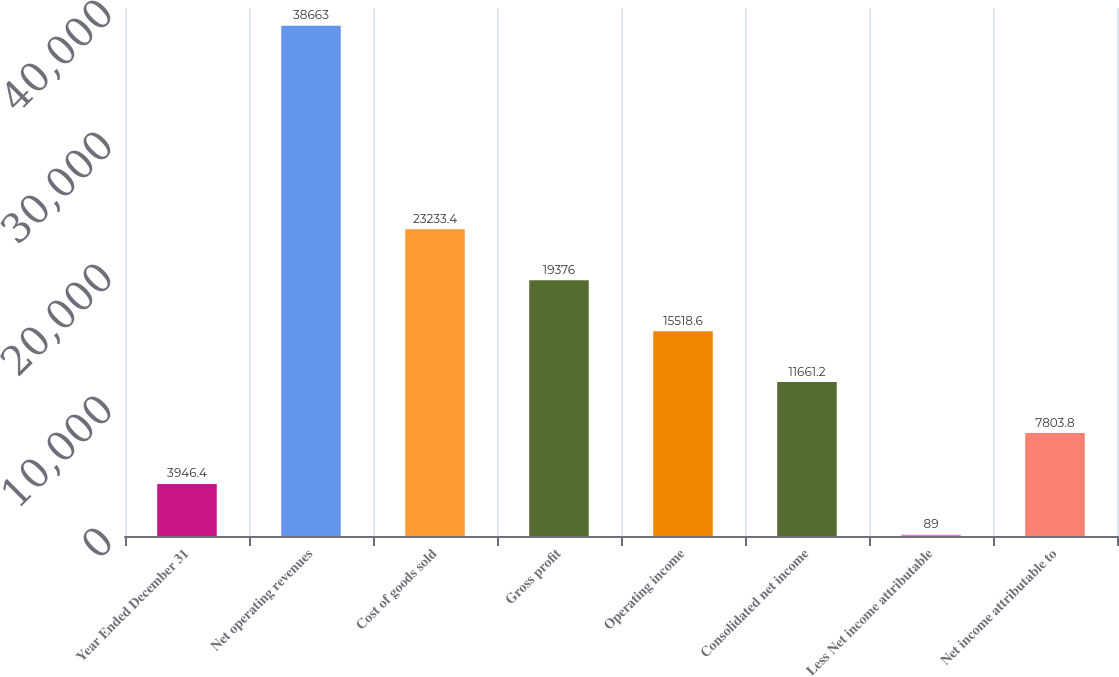Convert chart to OTSL. <chart><loc_0><loc_0><loc_500><loc_500><bar_chart><fcel>Year Ended December 31<fcel>Net operating revenues<fcel>Cost of goods sold<fcel>Gross profit<fcel>Operating income<fcel>Consolidated net income<fcel>Less Net income attributable<fcel>Net income attributable to<nl><fcel>3946.4<fcel>38663<fcel>23233.4<fcel>19376<fcel>15518.6<fcel>11661.2<fcel>89<fcel>7803.8<nl></chart> 